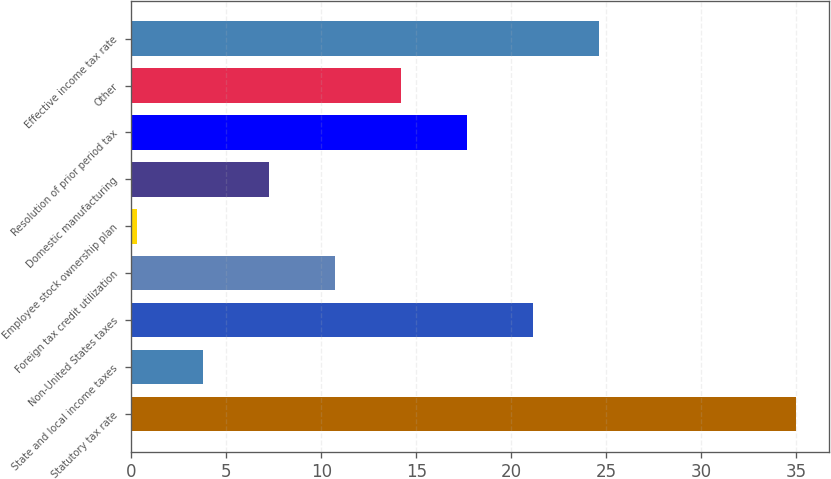Convert chart to OTSL. <chart><loc_0><loc_0><loc_500><loc_500><bar_chart><fcel>Statutory tax rate<fcel>State and local income taxes<fcel>Non-United States taxes<fcel>Foreign tax credit utilization<fcel>Employee stock ownership plan<fcel>Domestic manufacturing<fcel>Resolution of prior period tax<fcel>Other<fcel>Effective income tax rate<nl><fcel>35<fcel>3.77<fcel>21.12<fcel>10.71<fcel>0.3<fcel>7.24<fcel>17.65<fcel>14.18<fcel>24.59<nl></chart> 